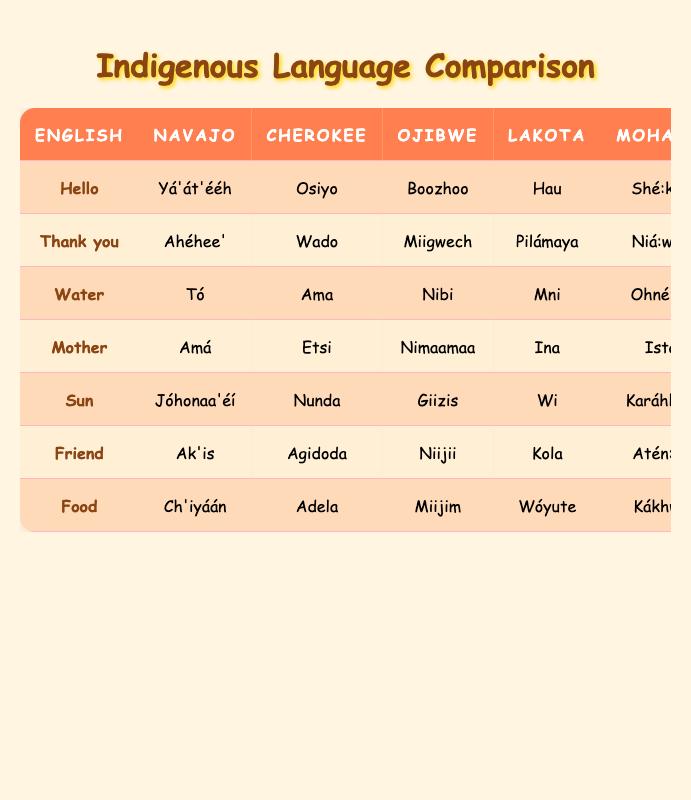What is the Navajo word for "Friend"? The table lists the English word "Friend" in the first column and the corresponding Navajo translation in the second column. For "Friend," the Navajo translation is provided directly next to it as "Ak'is."
Answer: Ak'is What does "Nibi" mean in English? In the Ojibwe column, the word "Nibi" is listed, and by referring to the English column, it is directly aligned with the word "Water." Therefore, "Nibi" translates to "Water" in English.
Answer: Water Is "Hau" the Lakota word for "Hello"? The table shows the word "Hello" in the English column, with its Lakota translation aligned in the corresponding column. The Lakota word is "Hau." Thus, the statement is true.
Answer: Yes Which Indigenous language translates "Sun" as "Jóhonaa'éí"? To answer this, look under the English word "Sun" in the table. The corresponding translation for "Sun" in the Navajo column is "Jóhonaa'éí." Therefore, the language is Navajo.
Answer: Navajo Count how many languages have the word "Food." The word "Food" appears in all five languages listed. To find this, look at the table's row for "Food," where there are translations provided for all five languages (Navajo, Cherokee, Ojibwe, Lakota, Mohawk). Since each language has a translation, there are five in total.
Answer: 5 Which word is translated as "Niijii" in Ojibwe? Looking at the table, find the Ojibwe translation "Niijii." Referring to the English column, "Niijii" corresponds to "Friend." Therefore, the English meaning of "Niijii" is "Friend."
Answer: Friend Does "Ama" mean "Mother" in Cherokee? To verify this, check the Cherokee column next to the English word "Mother." The translation provided in the Cherokee column is "Etsi," not "Ama." Therefore, the statement is false.
Answer: No What is the difference between the English translations for "Thank you" and "Food"? In the table, "Thank you" translates to "Ahéhee'" in Navajo and "Food" translates to "Ch'iyáán." The difference is between the activities they represent with respect to gratitude versus nourishment. The translations signify different concepts rather than a numerical difference that can be calculated, meaning they refer to completely different parts of life.
Answer: Different concepts What is the Mohawk word for "Water"? To find the Mohawk translation for "Water," look under the English word "Water" and find the corresponding translation in the Mohawk column. The Mohawk translation is "Ohné:ka."
Answer: Ohné:ka 